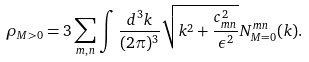<formula> <loc_0><loc_0><loc_500><loc_500>\rho _ { M > 0 } = 3 \sum _ { m , n } \int \frac { d ^ { 3 } k } { ( 2 \pi ) ^ { 3 } } \sqrt { k ^ { 2 } + \frac { c _ { m n } ^ { 2 } } { \epsilon ^ { 2 } } } N ^ { m n } _ { M = 0 } ( k ) .</formula> 